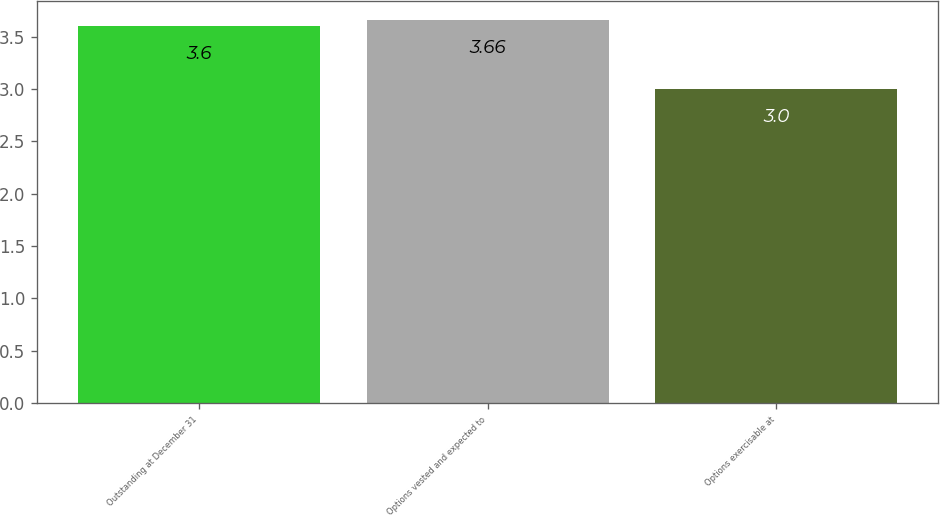Convert chart. <chart><loc_0><loc_0><loc_500><loc_500><bar_chart><fcel>Outstanding at December 31<fcel>Options vested and expected to<fcel>Options exercisable at<nl><fcel>3.6<fcel>3.66<fcel>3<nl></chart> 